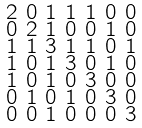<formula> <loc_0><loc_0><loc_500><loc_500>\begin{smallmatrix} 2 & 0 & 1 & 1 & 1 & 0 & 0 \\ 0 & 2 & 1 & 0 & 0 & 1 & 0 \\ 1 & 1 & 3 & 1 & 1 & 0 & 1 \\ 1 & 0 & 1 & 3 & 0 & 1 & 0 \\ 1 & 0 & 1 & 0 & 3 & 0 & 0 \\ 0 & 1 & 0 & 1 & 0 & 3 & 0 \\ 0 & 0 & 1 & 0 & 0 & 0 & 3 \end{smallmatrix}</formula> 